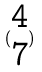Convert formula to latex. <formula><loc_0><loc_0><loc_500><loc_500>( \begin{matrix} 4 \\ 7 \end{matrix} )</formula> 